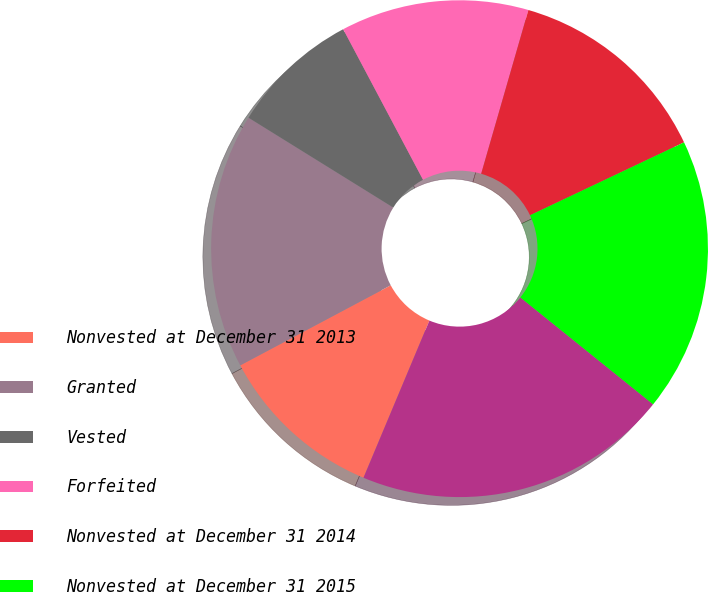Convert chart to OTSL. <chart><loc_0><loc_0><loc_500><loc_500><pie_chart><fcel>Nonvested at December 31 2013<fcel>Granted<fcel>Vested<fcel>Forfeited<fcel>Nonvested at December 31 2014<fcel>Nonvested at December 31 2015<fcel>Forfeited Nonvested at<nl><fcel>10.9%<fcel>16.62%<fcel>8.4%<fcel>12.23%<fcel>13.49%<fcel>17.83%<fcel>20.53%<nl></chart> 